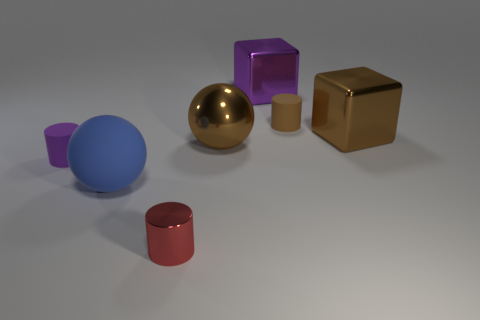The large shiny object that is the same color as the metal ball is what shape?
Offer a very short reply. Cube. There is a cube behind the thing that is right of the tiny cylinder that is behind the small purple rubber thing; what is it made of?
Provide a succinct answer. Metal. The purple thing in front of the tiny brown thing that is behind the tiny purple matte cylinder is made of what material?
Your answer should be compact. Rubber. There is a rubber cylinder to the right of the metallic sphere; does it have the same size as the ball that is on the left side of the tiny red cylinder?
Ensure brevity in your answer.  No. What number of big objects are either blue rubber balls or shiny things?
Your response must be concise. 4. How many things are purple shiny blocks that are behind the small red shiny cylinder or purple spheres?
Your response must be concise. 1. How many other objects are there of the same shape as the purple shiny object?
Your answer should be compact. 1. How many blue objects are big shiny spheres or big metal things?
Your response must be concise. 0. There is a sphere that is made of the same material as the purple cylinder; what color is it?
Offer a terse response. Blue. Does the ball to the left of the small red shiny thing have the same material as the big brown object on the right side of the big metal ball?
Give a very brief answer. No. 